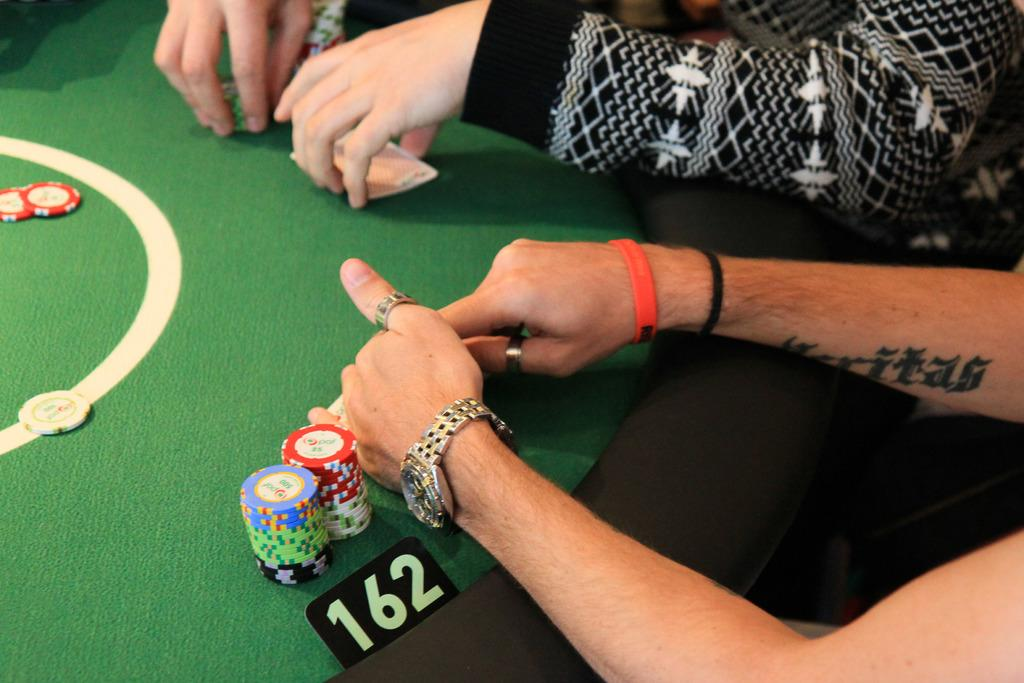What objects are on the game board in the image? There are coins on the game board. What additional information is provided on the game board? There is a number tag on the game board. What actions are the persons in the image performing? Two persons' hands are holding cards and coins. What type of grass can be seen growing on the seat in the image? There is no grass or seat present in the image; it features a game board with coins and a number tag. 